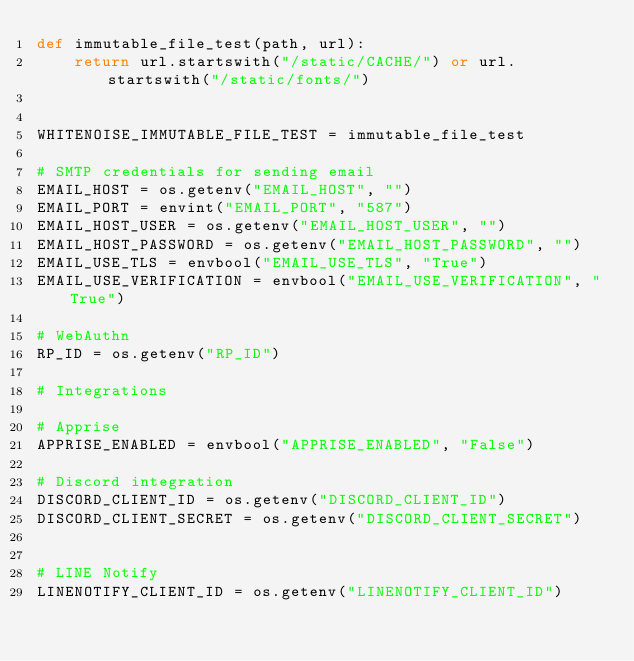Convert code to text. <code><loc_0><loc_0><loc_500><loc_500><_Python_>def immutable_file_test(path, url):
    return url.startswith("/static/CACHE/") or url.startswith("/static/fonts/")


WHITENOISE_IMMUTABLE_FILE_TEST = immutable_file_test

# SMTP credentials for sending email
EMAIL_HOST = os.getenv("EMAIL_HOST", "")
EMAIL_PORT = envint("EMAIL_PORT", "587")
EMAIL_HOST_USER = os.getenv("EMAIL_HOST_USER", "")
EMAIL_HOST_PASSWORD = os.getenv("EMAIL_HOST_PASSWORD", "")
EMAIL_USE_TLS = envbool("EMAIL_USE_TLS", "True")
EMAIL_USE_VERIFICATION = envbool("EMAIL_USE_VERIFICATION", "True")

# WebAuthn
RP_ID = os.getenv("RP_ID")

# Integrations

# Apprise
APPRISE_ENABLED = envbool("APPRISE_ENABLED", "False")

# Discord integration
DISCORD_CLIENT_ID = os.getenv("DISCORD_CLIENT_ID")
DISCORD_CLIENT_SECRET = os.getenv("DISCORD_CLIENT_SECRET")


# LINE Notify
LINENOTIFY_CLIENT_ID = os.getenv("LINENOTIFY_CLIENT_ID")</code> 